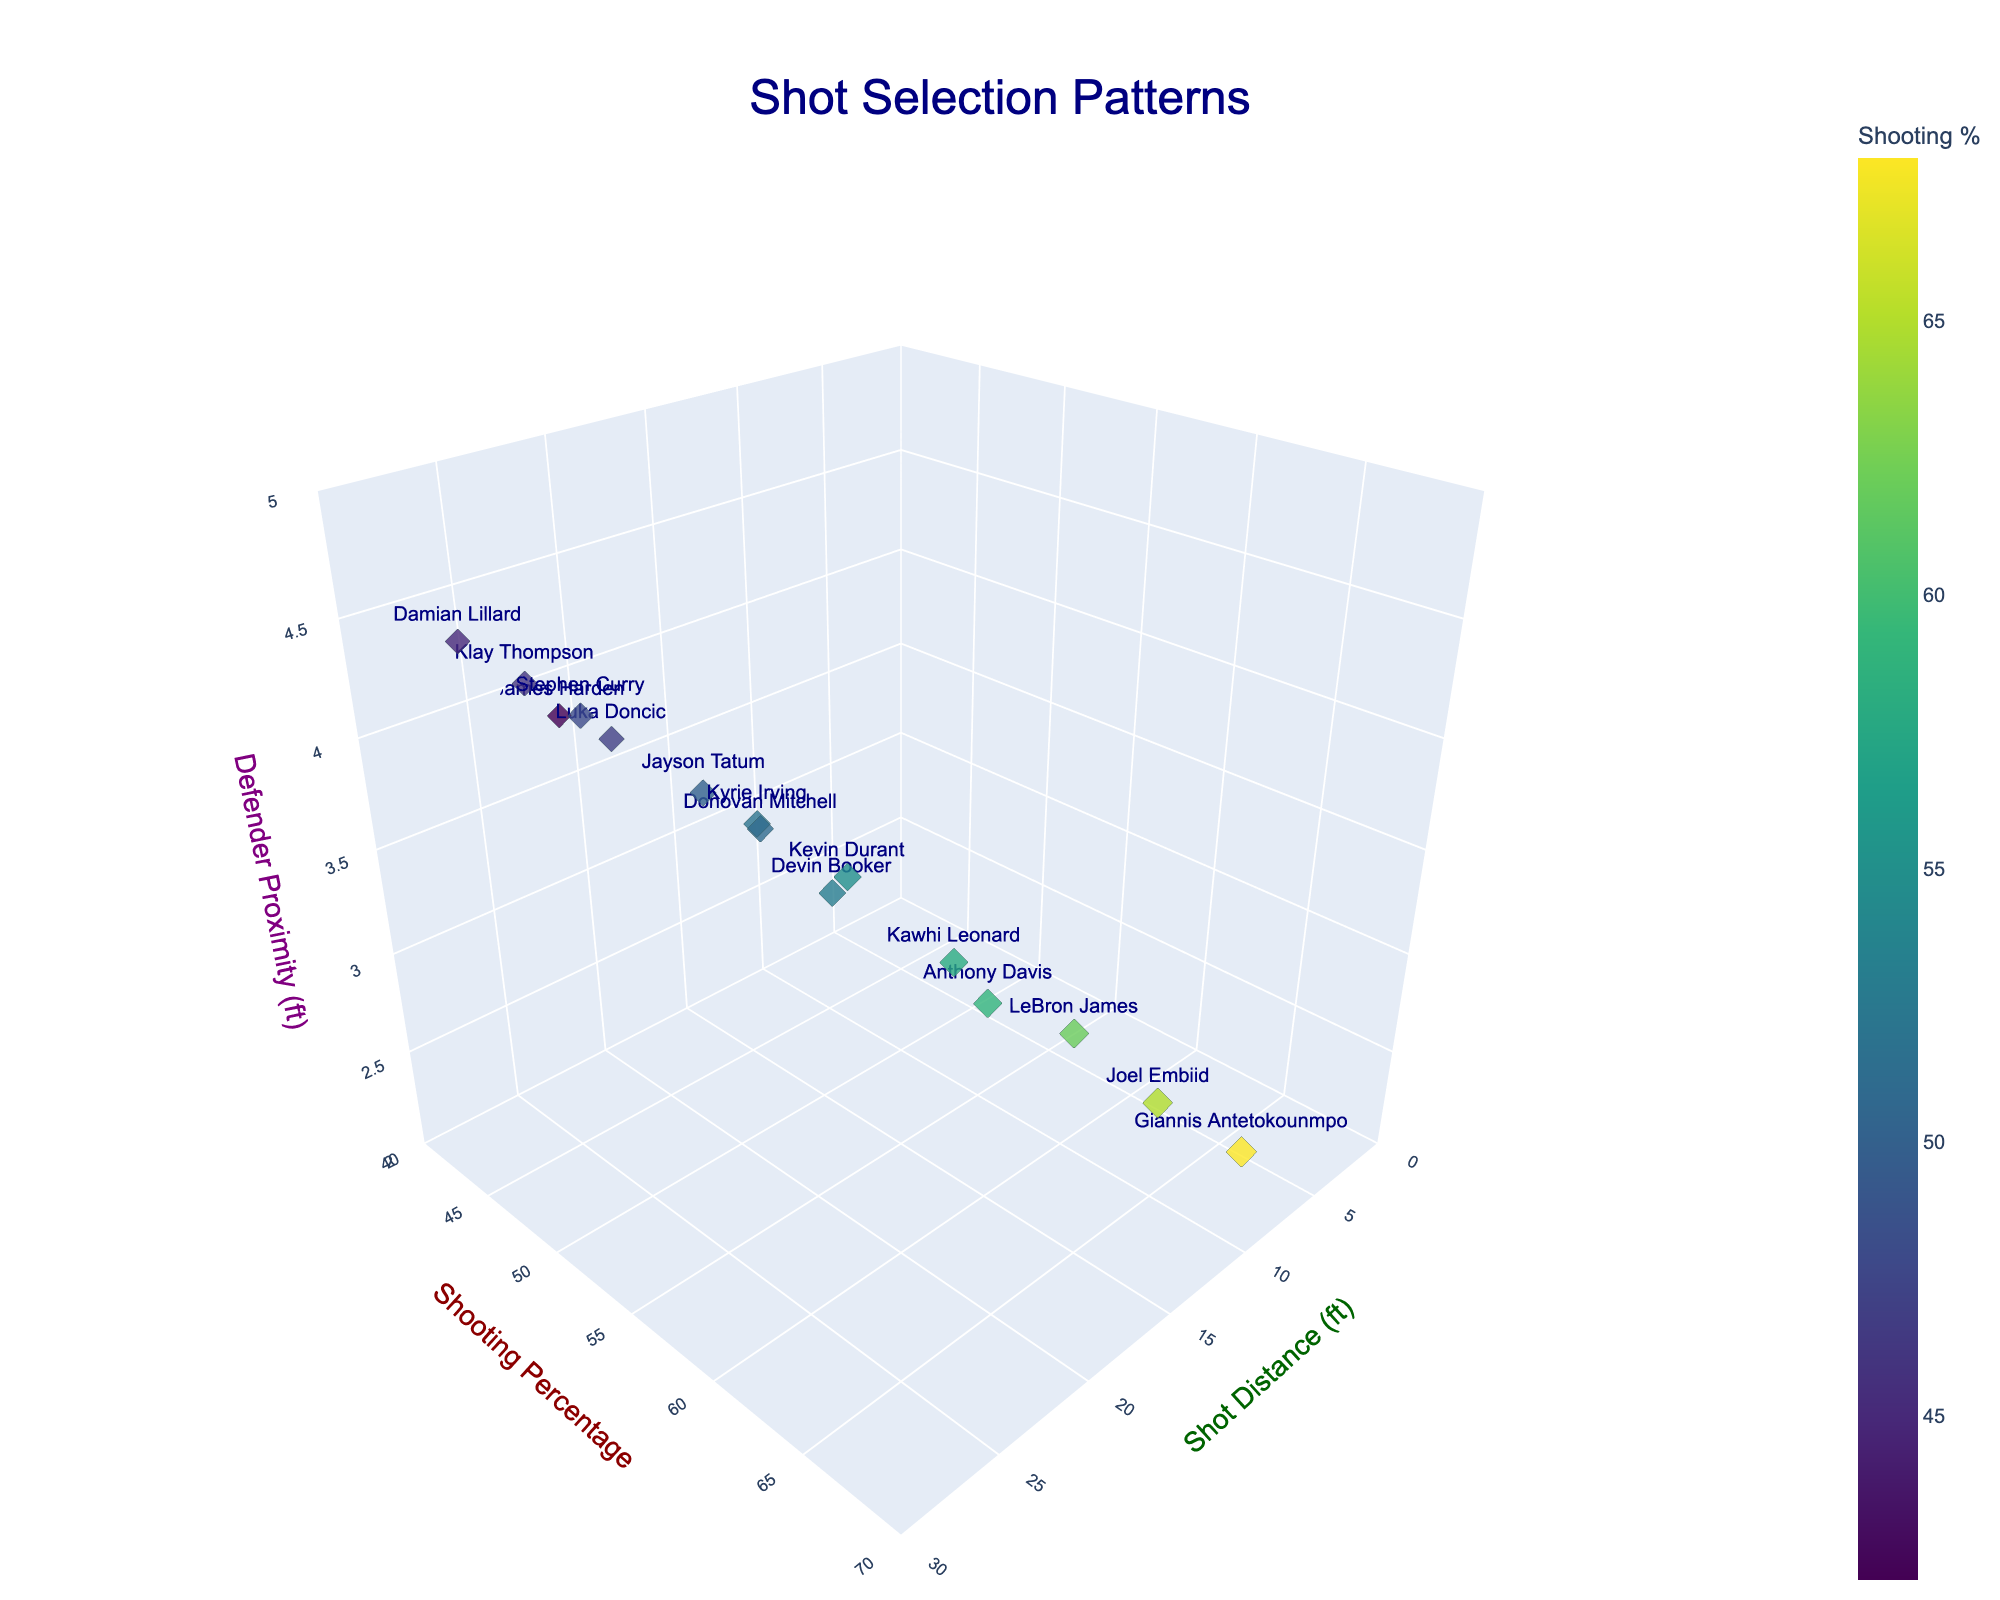Which player has the highest shooting percentage? Locate the data points with the highest y-axis (Shooting Percentage). Point closest to 70 is Giannis Antetokounmpo.
Answer: Giannis Antetokounmpo What is the shot distance for Joel Embiid? Find the data point labeled "Joel Embiid", then check its position on the x-axis (Shot Distance). Joel Embiid's position on x-axis is around 10.
Answer: 10 ft Who is closest to their defender during shots? Look at the data points with the lowest position on the z-axis (Defender Proximity). The lowest point on the z-axis is Giannis Antetokounmpo around 2.3 ft.
Answer: Giannis Antetokounmpo Which player takes the longest shots? Identify the data point farthest along the x-axis (Shot Distance). Damian Lillard's position is at 28 ft, furthest along x-axis.
Answer: Damian Lillard Who besides Giannis Antetokounmpo has a high shooting percentage? Find data points above 55% on the y-axis and exclude Giannis Antetokounmpo's point. LeBron James (62%), Kawhi Leonard (58%), Joel Embiid (65%), Anthony Davis (59%).
Answer: LeBron James, Kawhi Leonard, Joel Embiid, Anthony Davis What is the average defender proximity for shots taken from 20 ft or more? Locate data points with x-axis values of 20 or more. Calculate the mean of their z-axis values (Defender Proximity). Calculating, we get (3.7+4.0+4.5+4.3)/4 = 4.125.
Answer: 4.125 ft Compare Steph Curry and Klay Thompson's shooting percentages. Who is better? Identify the positions of Steph Curry and Klay Thompson. Compare their y-values (Shooting Percentage). Steph Curry (48%) is compared to Klay Thompson (46%).
Answer: Steph Curry Whose shots are most contested on average, between LeBron James and Anthony Davis? Compare the z-axis (Defender Proximity) values for LeBron James and Anthony Davis. LeBron James: 2.8 ft, Anthony Davis: 2.9 ft, LeBron James has a smaller value.
Answer: LeBron James What is the title of the plot? Look at the central text above the plot, which labels it. The title reads "Shot Selection Patterns".
Answer: Shot Selection Patterns 